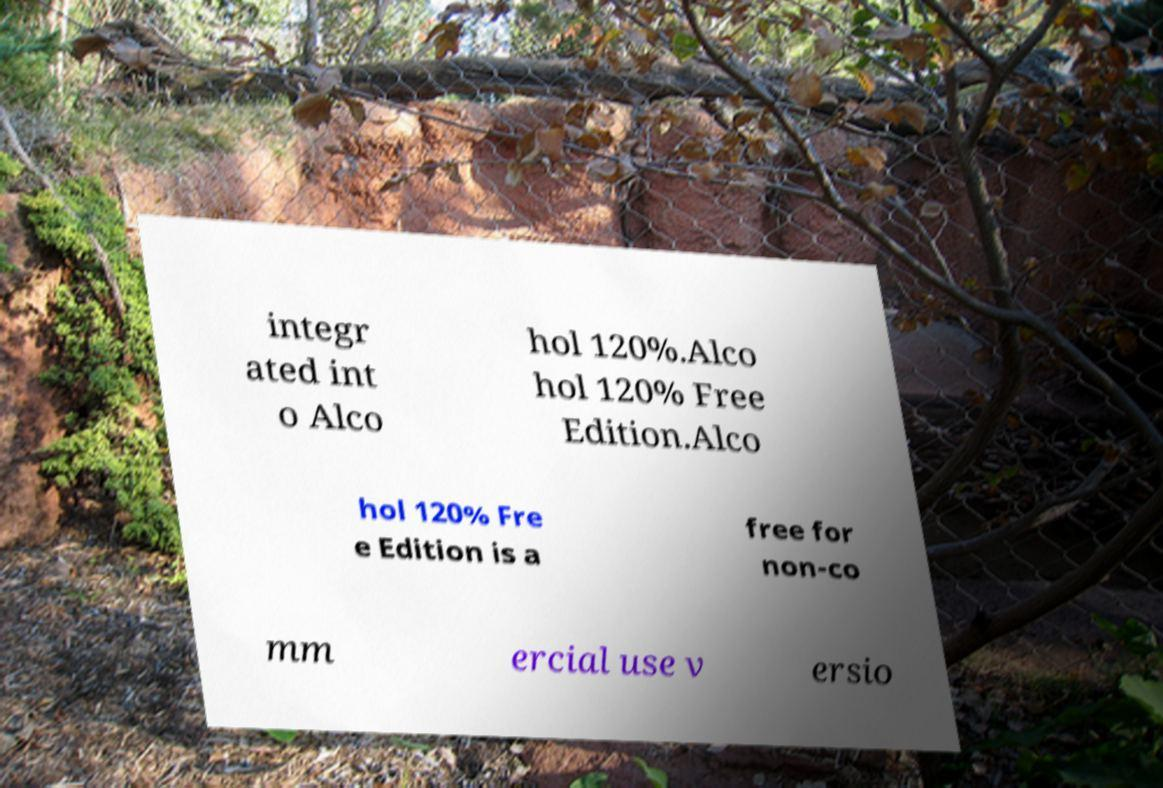For documentation purposes, I need the text within this image transcribed. Could you provide that? integr ated int o Alco hol 120%.Alco hol 120% Free Edition.Alco hol 120% Fre e Edition is a free for non-co mm ercial use v ersio 